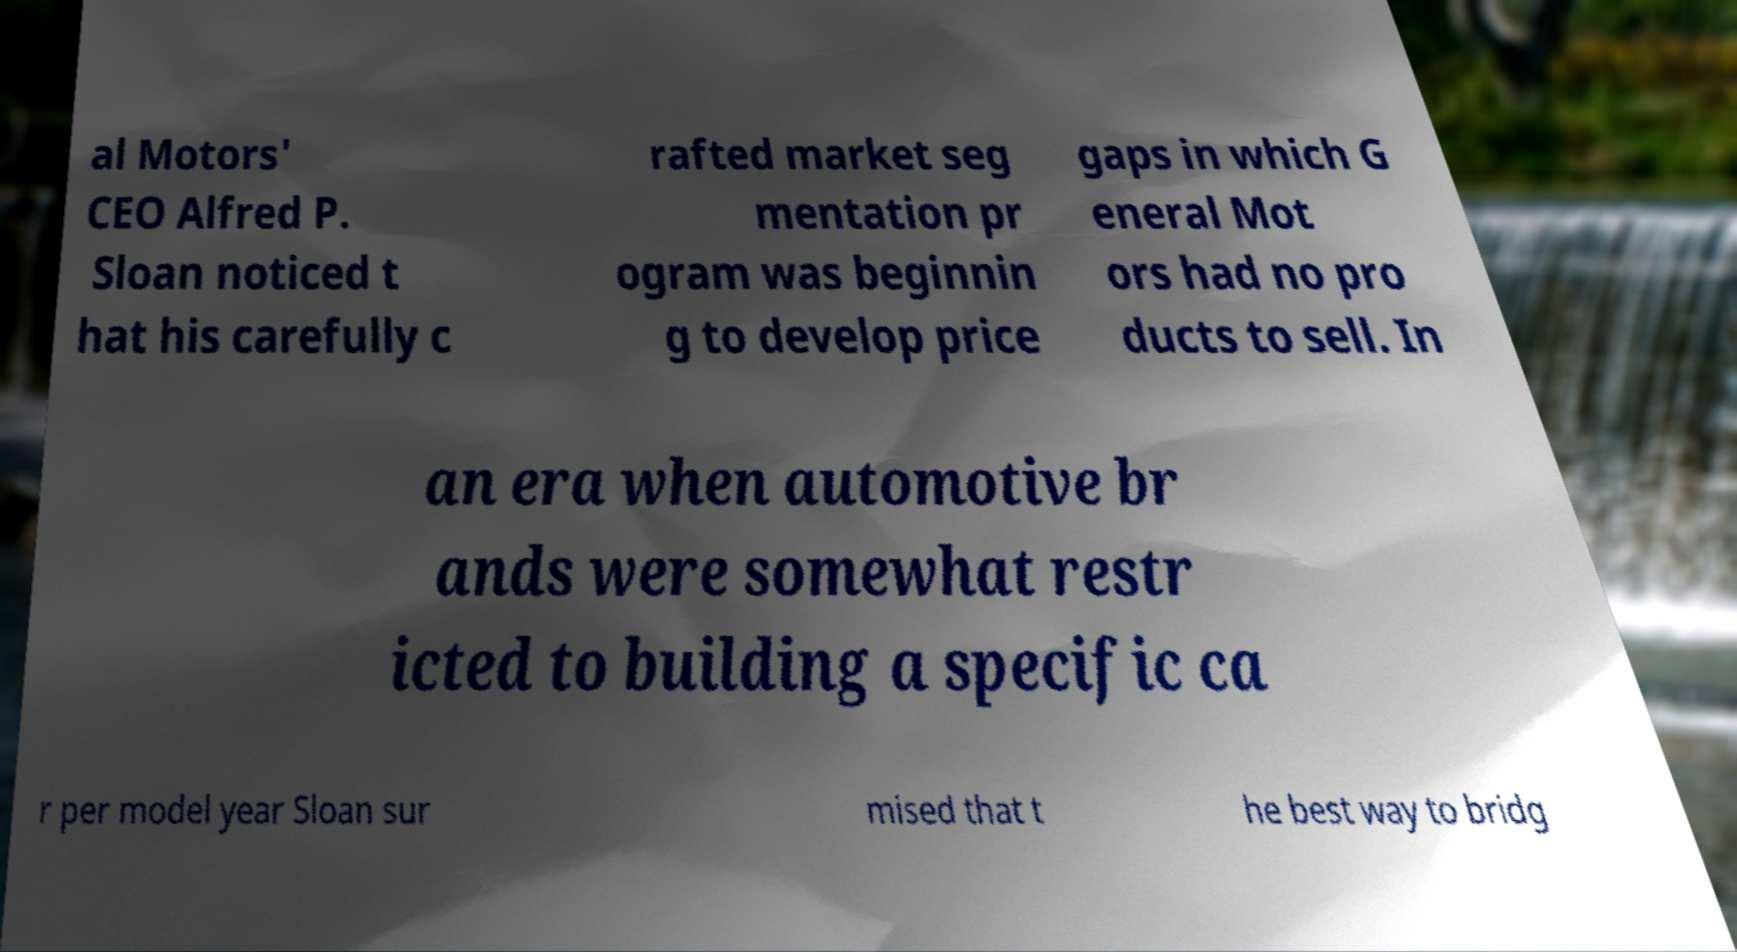For documentation purposes, I need the text within this image transcribed. Could you provide that? al Motors' CEO Alfred P. Sloan noticed t hat his carefully c rafted market seg mentation pr ogram was beginnin g to develop price gaps in which G eneral Mot ors had no pro ducts to sell. In an era when automotive br ands were somewhat restr icted to building a specific ca r per model year Sloan sur mised that t he best way to bridg 